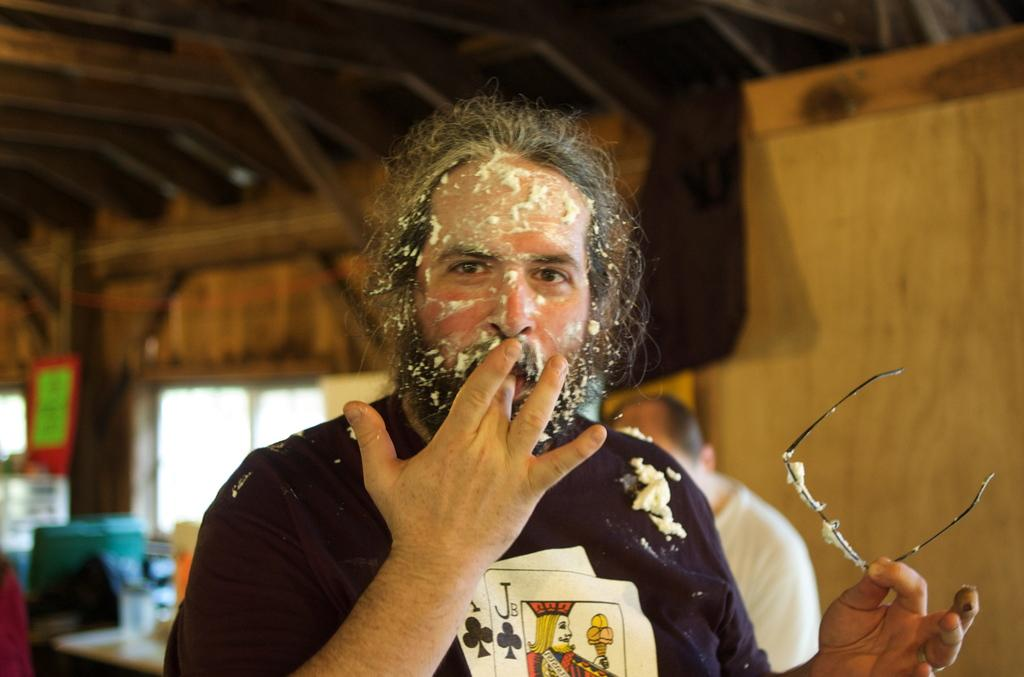Who is present in the image? There is a man in the image. What is the man holding in his hand? The man is holding a spectacle in his hand. What can be seen in the background of the image? There is a window, a wall, a poster, and some objects visible in the background of the image. What type of mint can be seen growing on the man's arm in the image? There is no mint visible in the image, nor is there any indication that the man has mint growing on his arm. 